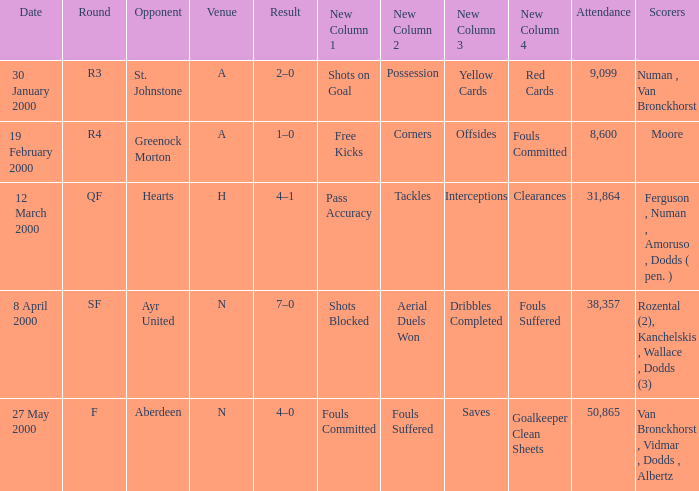What venue was on 27 May 2000? N. 